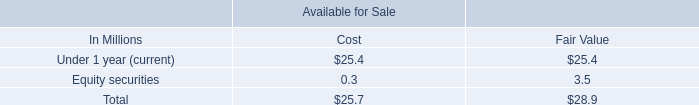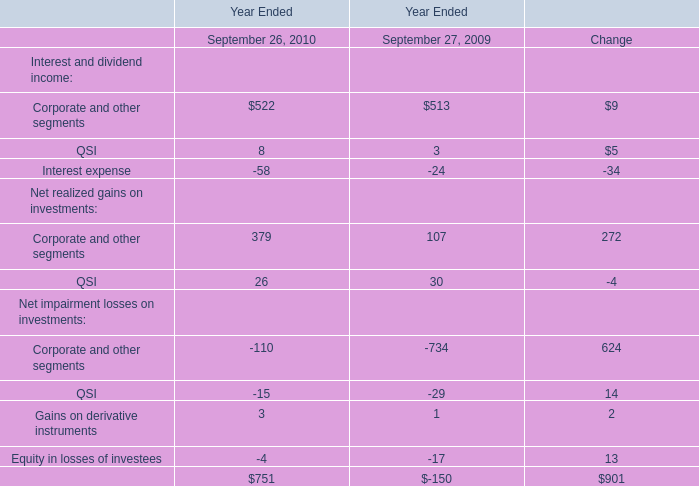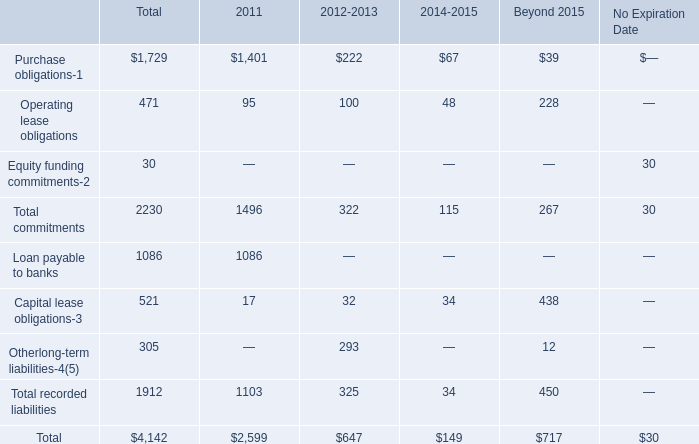What was the average of the Total commitments in the years where Operating lease obligations is positive? 
Computations: (((1496 + 322) + 115) / 3)
Answer: 644.33333. 